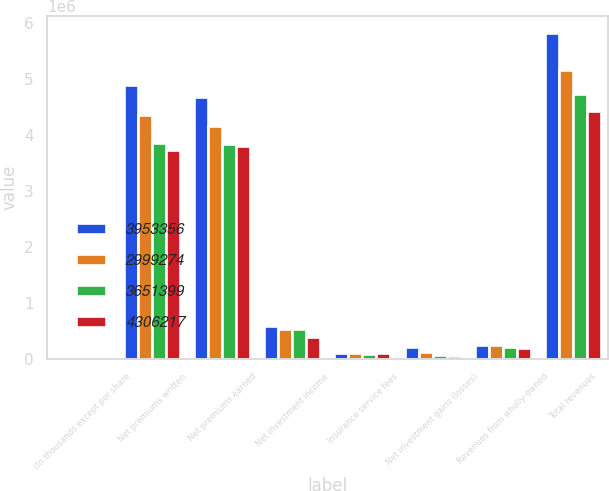<chart> <loc_0><loc_0><loc_500><loc_500><stacked_bar_chart><ecel><fcel>(In thousands except per share<fcel>Net premiums written<fcel>Net premiums earned<fcel>Net investment income<fcel>Insurance service fees<fcel>Net investment gains (losses)<fcel>Revenues from wholly-owned<fcel>Total revenues<nl><fcel>3.95336e+06<fcel>2012<fcel>4.89854e+06<fcel>4.67352e+06<fcel>586763<fcel>103133<fcel>210465<fcel>247113<fcel>5.82355e+06<nl><fcel>2.99927e+06<fcel>2011<fcel>4.35737e+06<fcel>4.16087e+06<fcel>526351<fcel>92843<fcel>125481<fcel>248678<fcel>5.15598e+06<nl><fcel>3.6514e+06<fcel>2010<fcel>3.85093e+06<fcel>3.83558e+06<fcel>530525<fcel>85405<fcel>56581<fcel>214454<fcel>4.72407e+06<nl><fcel>4.30622e+06<fcel>2009<fcel>3.7301e+06<fcel>3.80585e+06<fcel>379008<fcel>93245<fcel>38408<fcel>189347<fcel>4.43118e+06<nl></chart> 